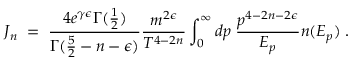Convert formula to latex. <formula><loc_0><loc_0><loc_500><loc_500>J _ { n } \, = \, { \frac { 4 e ^ { \gamma \epsilon } \Gamma ( { \frac { 1 } { 2 } } ) } { \Gamma ( { \frac { 5 } { 2 } } - n - \epsilon ) } } { \frac { m ^ { 2 \epsilon } } { T ^ { 4 - 2 n } } } \int _ { 0 } ^ { \infty } d p \, { \frac { p ^ { 4 - 2 n - 2 \epsilon } } { E _ { p } } } n ( E _ { p } ) \, .</formula> 